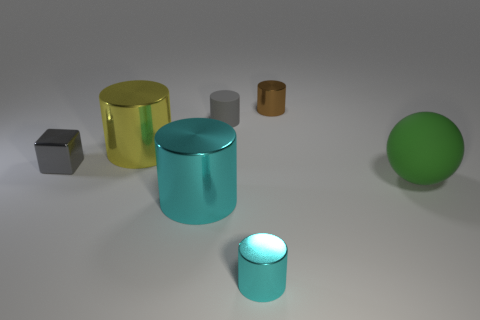Are there any objects that stand out to you for any reason? The large cyan cylinder grabs attention due to its vibrant color and reflective surface, making it a prominent element in this assortment of objects. Does the texture or material of the objects provide any clues about what they might be used for? The reflective surfaces of most objects suggest that they are made of some type of metal or plastic, materials often used for durable and functional items. However, without additional context, determining a specific use is challenging. 